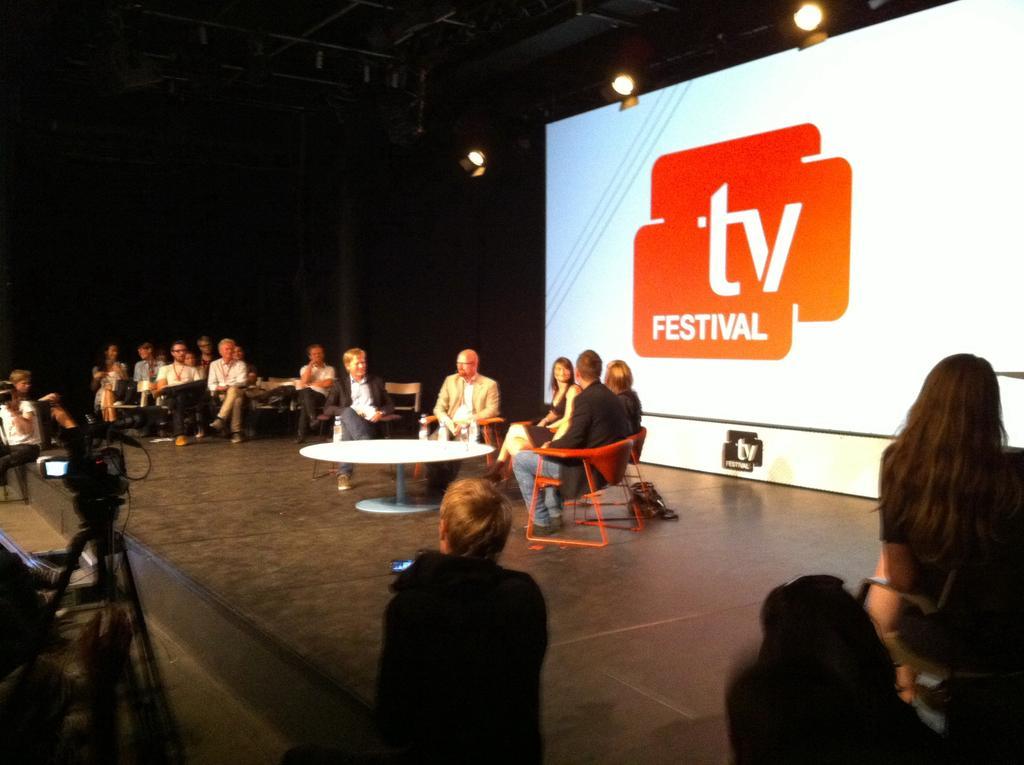In one or two sentences, can you explain what this image depicts? Here in this picture we can see number of people sitting on chairs present on floor and in the middle we can see a table also present and behind them we can see a projector screen with something projected on it and we can also see lights at the top and in the front we can see people standing with video cameras in front of them. 